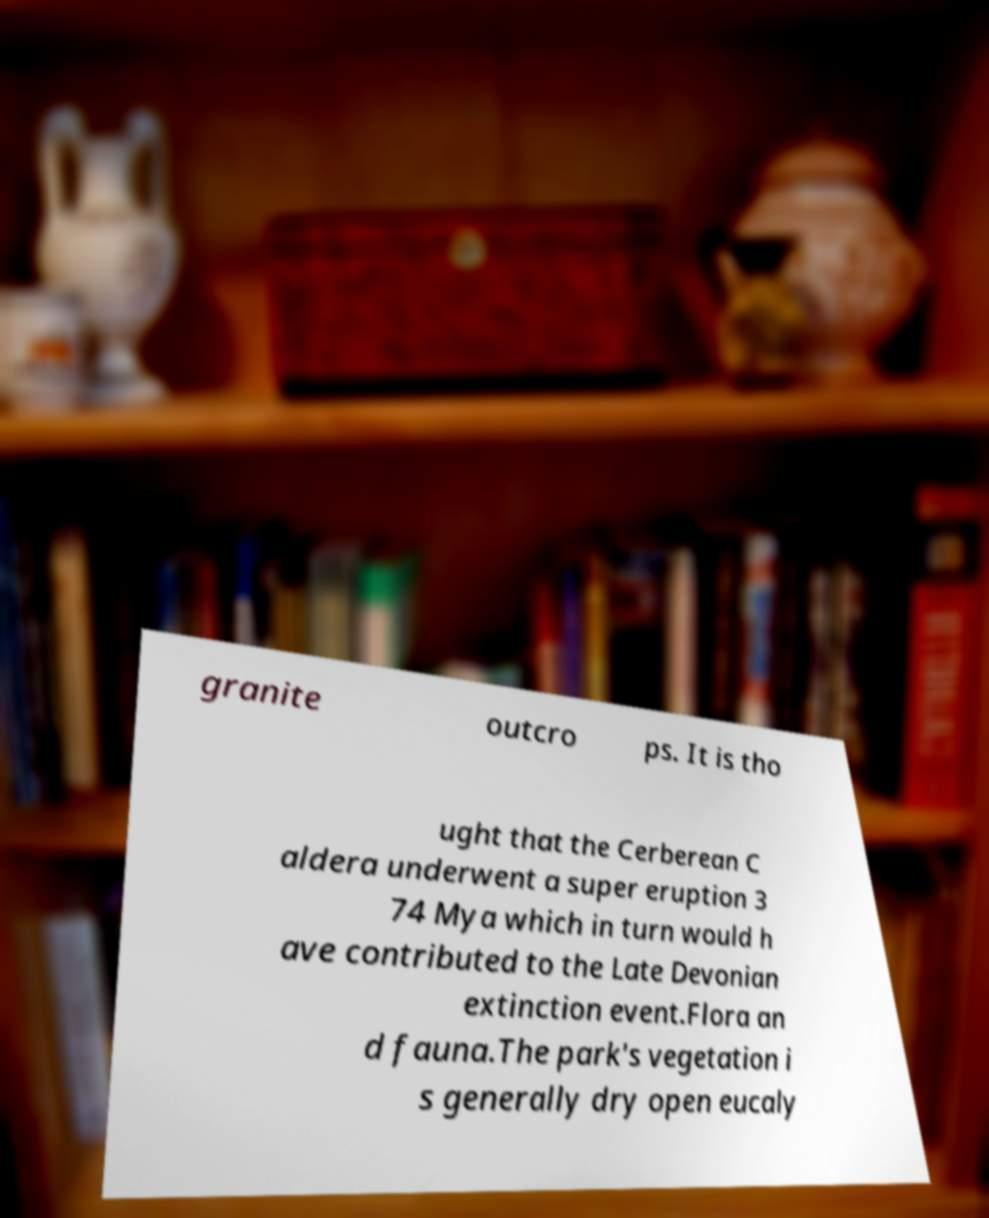Could you assist in decoding the text presented in this image and type it out clearly? granite outcro ps. It is tho ught that the Cerberean C aldera underwent a super eruption 3 74 Mya which in turn would h ave contributed to the Late Devonian extinction event.Flora an d fauna.The park's vegetation i s generally dry open eucaly 